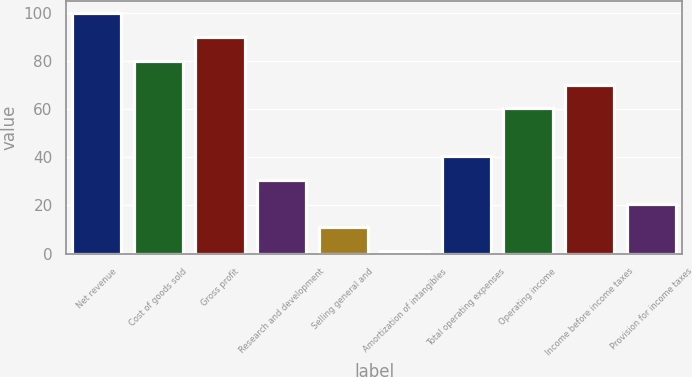Convert chart to OTSL. <chart><loc_0><loc_0><loc_500><loc_500><bar_chart><fcel>Net revenue<fcel>Cost of goods sold<fcel>Gross profit<fcel>Research and development<fcel>Selling general and<fcel>Amortization of intangibles<fcel>Total operating expenses<fcel>Operating income<fcel>Income before income taxes<fcel>Provision for income taxes<nl><fcel>100<fcel>80.2<fcel>90.1<fcel>30.7<fcel>10.9<fcel>1<fcel>40.6<fcel>60.4<fcel>70.3<fcel>20.8<nl></chart> 